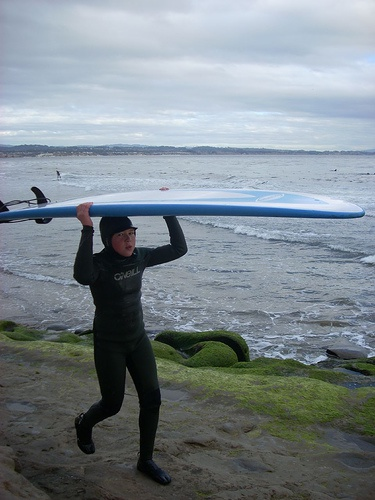Describe the objects in this image and their specific colors. I can see people in darkgray, black, gray, and maroon tones, surfboard in darkgray, lightgray, lightblue, blue, and darkblue tones, and people in darkgray, black, and gray tones in this image. 